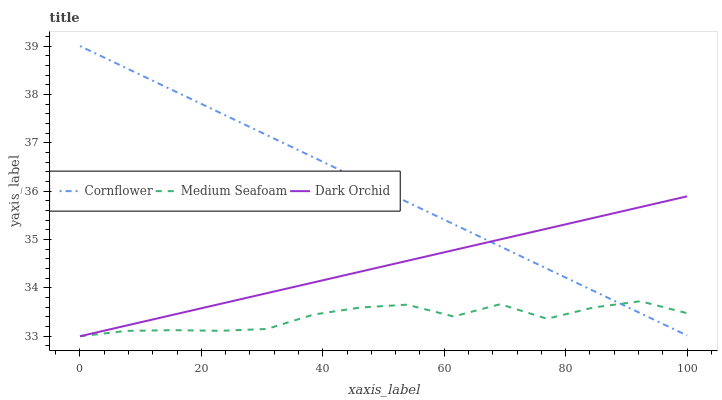Does Medium Seafoam have the minimum area under the curve?
Answer yes or no. Yes. Does Cornflower have the maximum area under the curve?
Answer yes or no. Yes. Does Dark Orchid have the minimum area under the curve?
Answer yes or no. No. Does Dark Orchid have the maximum area under the curve?
Answer yes or no. No. Is Cornflower the smoothest?
Answer yes or no. Yes. Is Medium Seafoam the roughest?
Answer yes or no. Yes. Is Dark Orchid the smoothest?
Answer yes or no. No. Is Dark Orchid the roughest?
Answer yes or no. No. Does Medium Seafoam have the lowest value?
Answer yes or no. Yes. Does Cornflower have the highest value?
Answer yes or no. Yes. Does Dark Orchid have the highest value?
Answer yes or no. No. Does Medium Seafoam intersect Dark Orchid?
Answer yes or no. Yes. Is Medium Seafoam less than Dark Orchid?
Answer yes or no. No. Is Medium Seafoam greater than Dark Orchid?
Answer yes or no. No. 